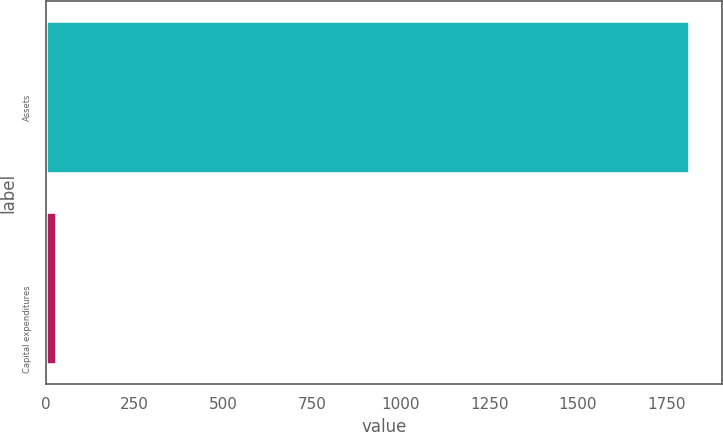Convert chart. <chart><loc_0><loc_0><loc_500><loc_500><bar_chart><fcel>Assets<fcel>Capital expenditures<nl><fcel>1815<fcel>33<nl></chart> 